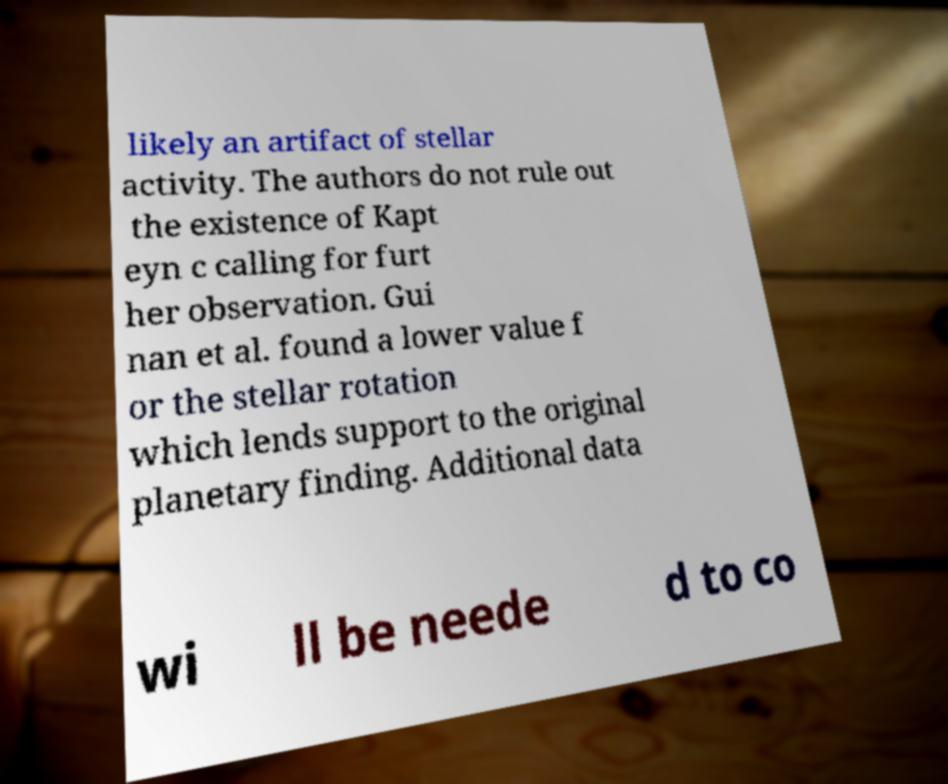For documentation purposes, I need the text within this image transcribed. Could you provide that? likely an artifact of stellar activity. The authors do not rule out the existence of Kapt eyn c calling for furt her observation. Gui nan et al. found a lower value f or the stellar rotation which lends support to the original planetary finding. Additional data wi ll be neede d to co 